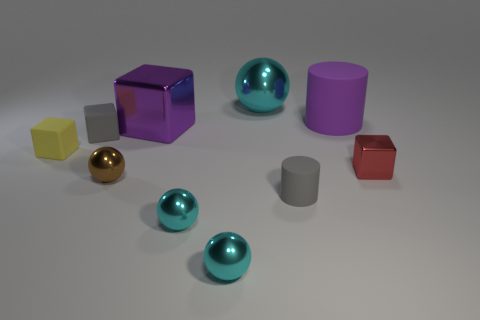How many cyan balls must be subtracted to get 1 cyan balls? 2 Subtract all brown cubes. How many cyan spheres are left? 3 Subtract all brown spheres. How many spheres are left? 3 Subtract all blocks. How many objects are left? 6 Subtract 0 blue cubes. How many objects are left? 10 Subtract all large cyan metal balls. Subtract all brown spheres. How many objects are left? 8 Add 2 big rubber cylinders. How many big rubber cylinders are left? 3 Add 10 small blue rubber cylinders. How many small blue rubber cylinders exist? 10 